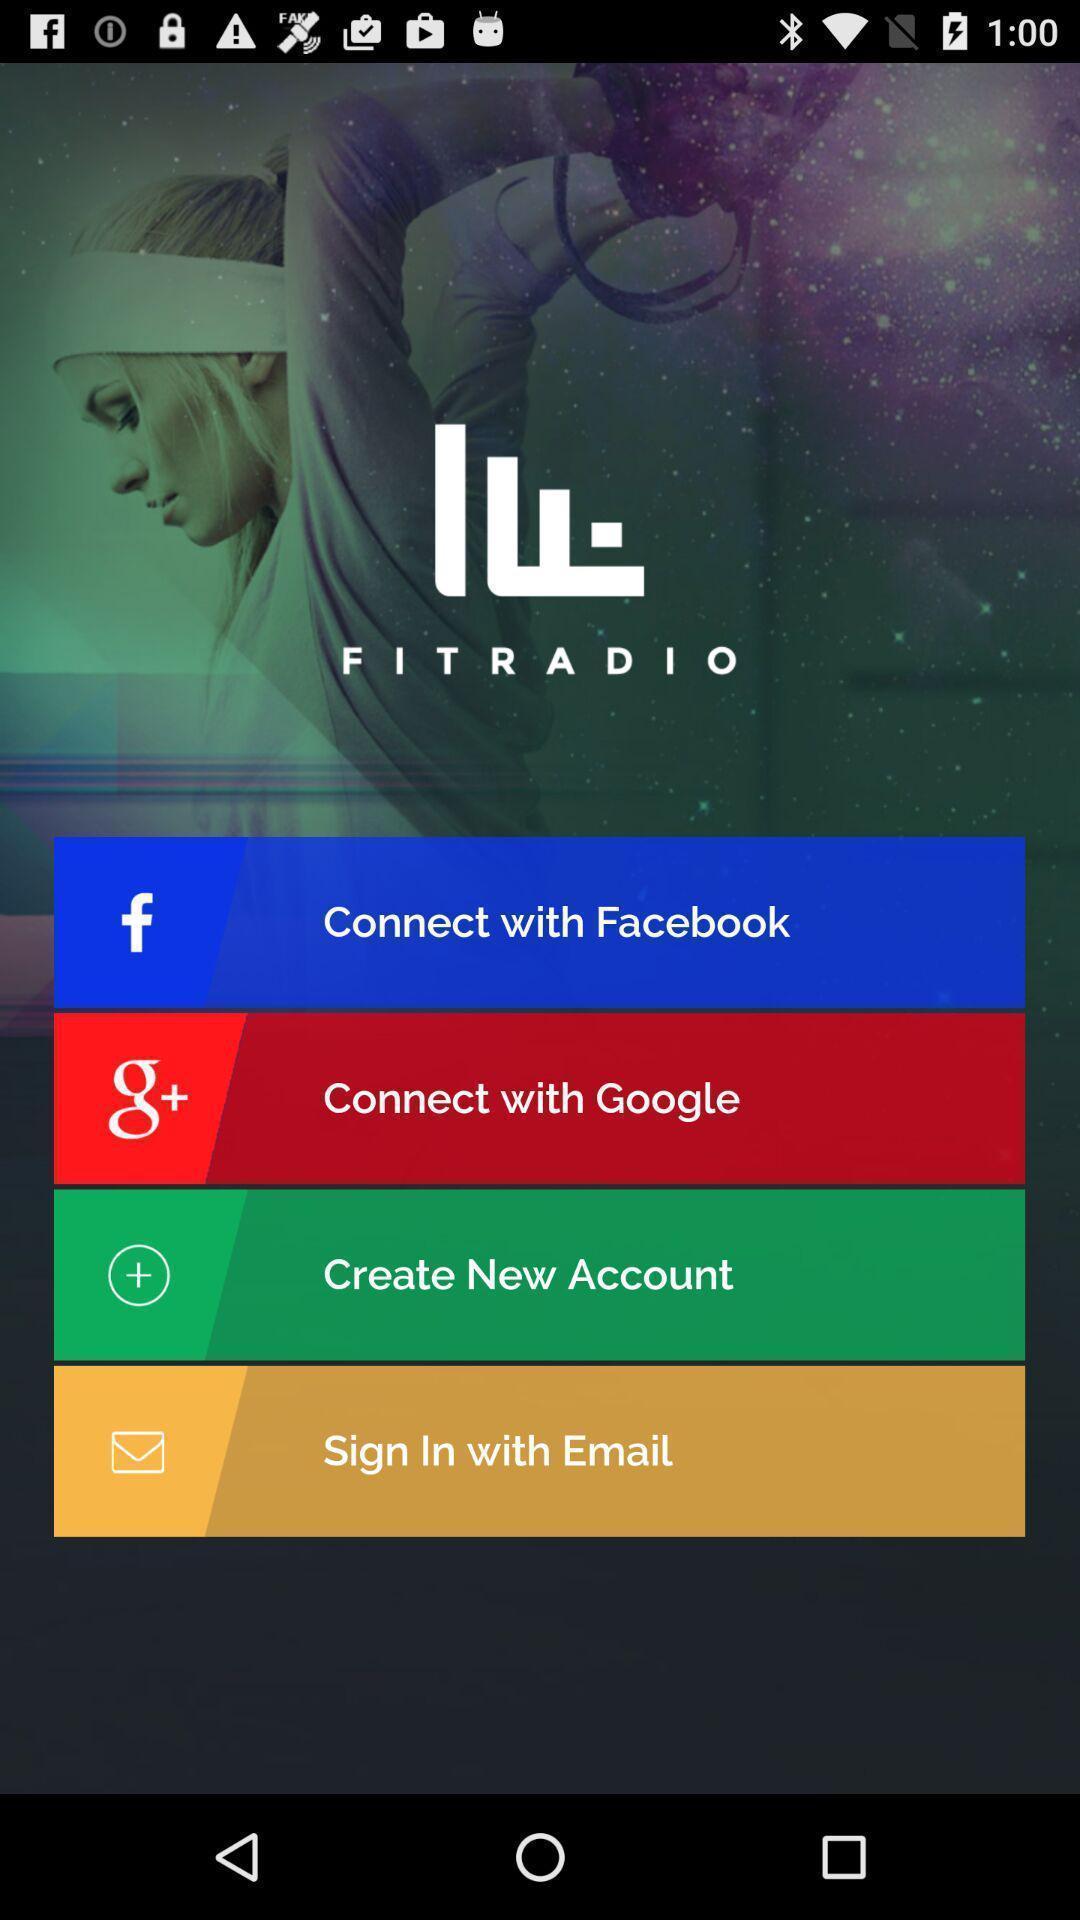Describe the key features of this screenshot. Sign in page for application. 